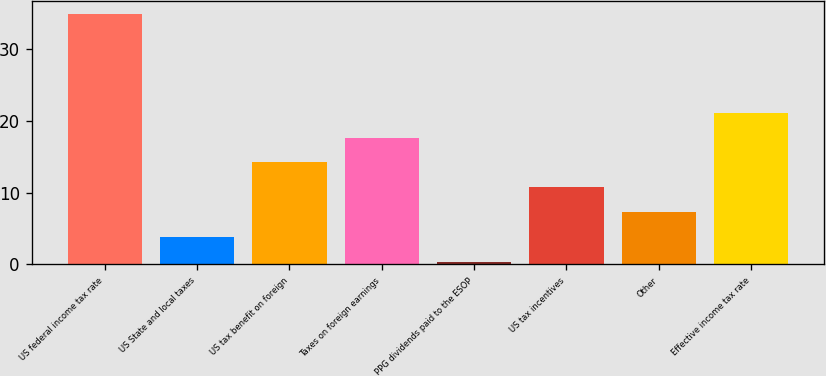Convert chart. <chart><loc_0><loc_0><loc_500><loc_500><bar_chart><fcel>US federal income tax rate<fcel>US State and local taxes<fcel>US tax benefit on foreign<fcel>Taxes on foreign earnings<fcel>PPG dividends paid to the ESOP<fcel>US tax incentives<fcel>Other<fcel>Effective income tax rate<nl><fcel>35<fcel>3.86<fcel>14.24<fcel>17.7<fcel>0.4<fcel>10.78<fcel>7.32<fcel>21.16<nl></chart> 